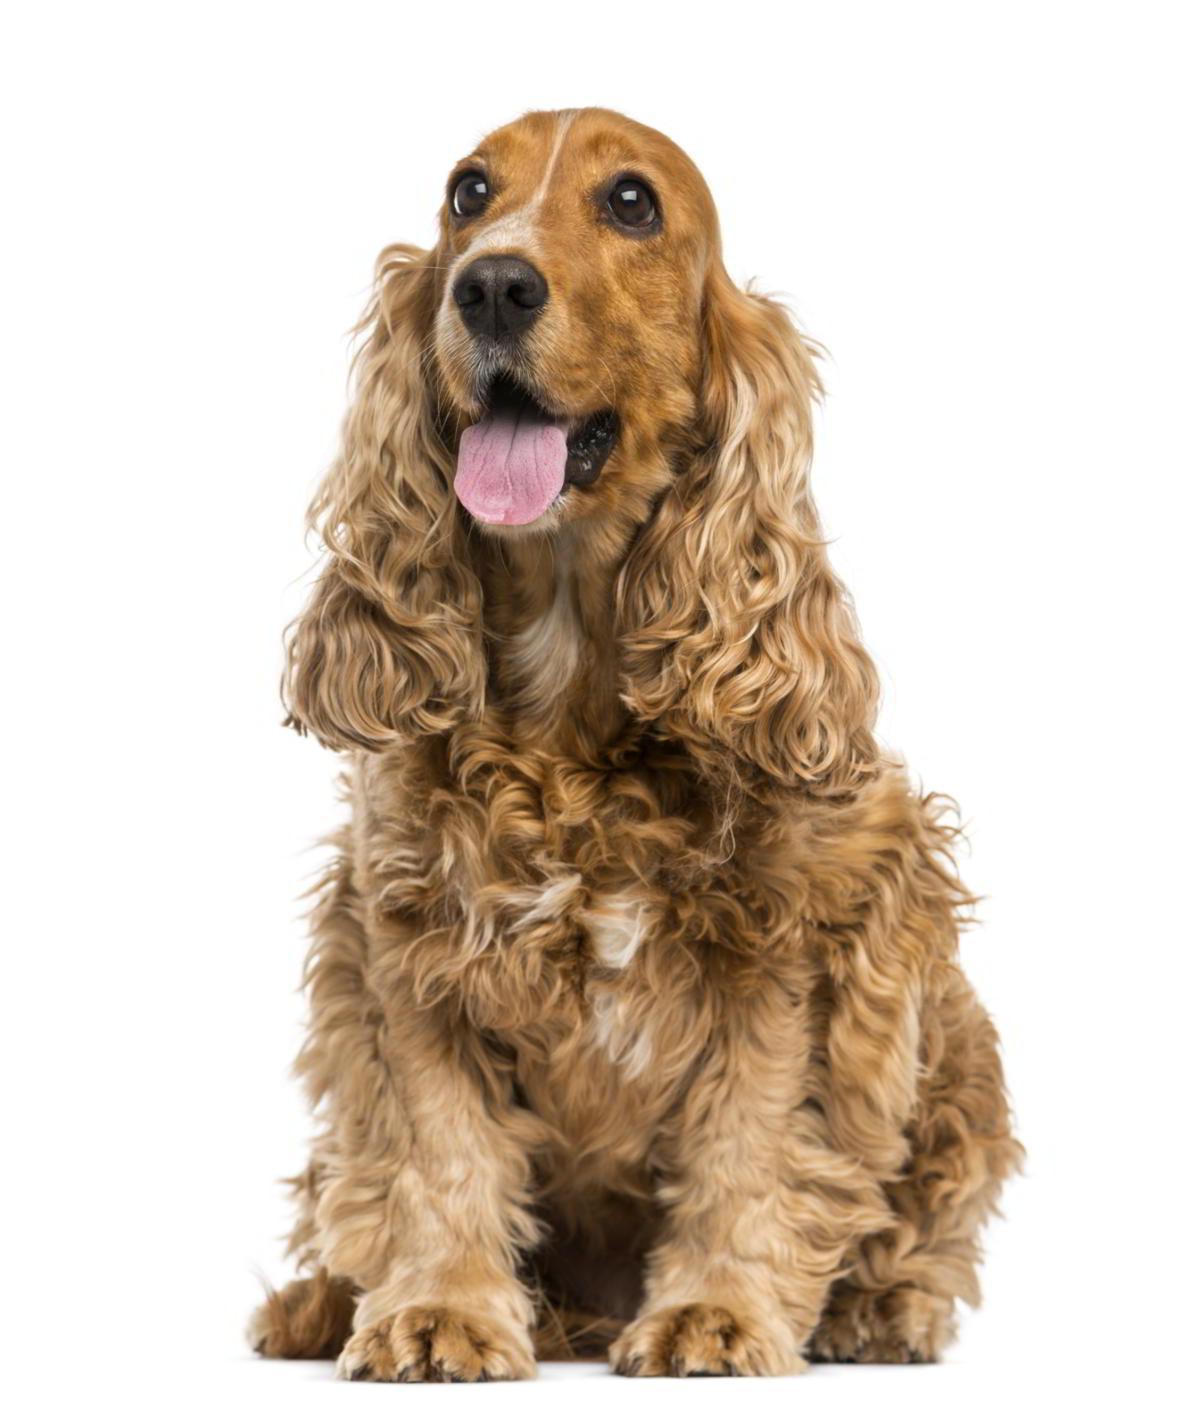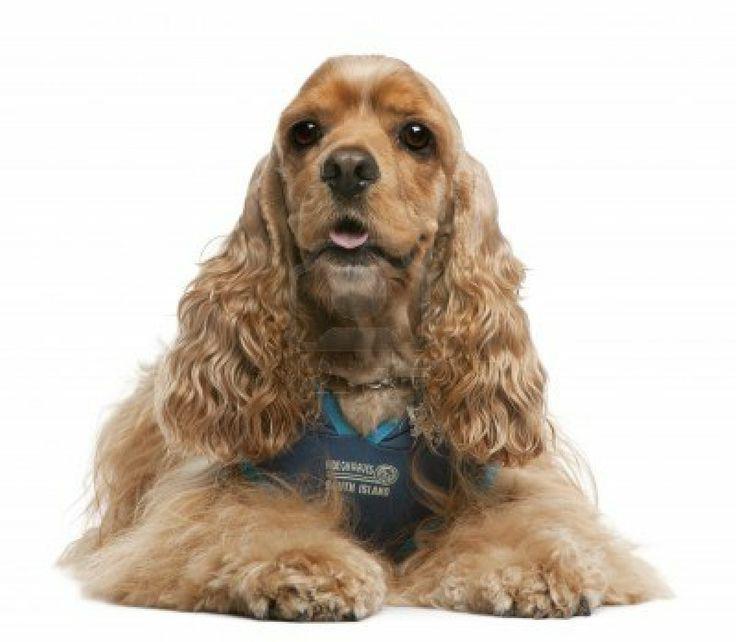The first image is the image on the left, the second image is the image on the right. Assess this claim about the two images: "One dog is sitting and one is laying down.". Correct or not? Answer yes or no. Yes. The first image is the image on the left, the second image is the image on the right. For the images displayed, is the sentence "One image contains a 'ginger' cocker spaniel sitting upright, and the other contains a 'ginger' cocker spaniel in a reclining pose." factually correct? Answer yes or no. Yes. 